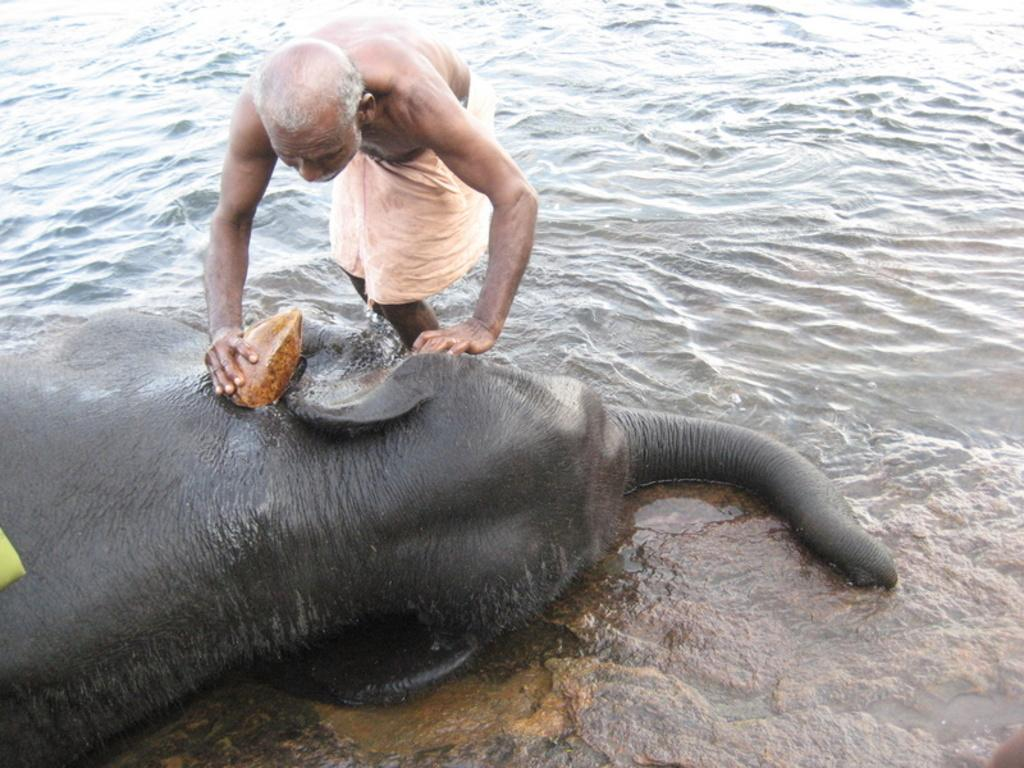Who is the main subject in the image? There is an old man in the image. What is the old man doing in the image? The old man is likely washing the elephant. What is lying in front of the old man? There is an elephant lying in front of the old man. What can be seen in the background of the image? Water is visible behind the old man and the elephant. What statement is the elephant making in the image? Elephants do not make statements; they are animals and cannot speak. What type of yarn is the old man using to wash the elephant? There is no yarn present in the image; the old man is likely using water to wash the elephant. 